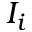Convert formula to latex. <formula><loc_0><loc_0><loc_500><loc_500>I _ { i }</formula> 